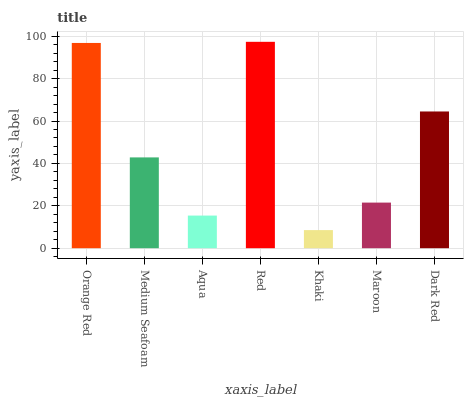Is Khaki the minimum?
Answer yes or no. Yes. Is Red the maximum?
Answer yes or no. Yes. Is Medium Seafoam the minimum?
Answer yes or no. No. Is Medium Seafoam the maximum?
Answer yes or no. No. Is Orange Red greater than Medium Seafoam?
Answer yes or no. Yes. Is Medium Seafoam less than Orange Red?
Answer yes or no. Yes. Is Medium Seafoam greater than Orange Red?
Answer yes or no. No. Is Orange Red less than Medium Seafoam?
Answer yes or no. No. Is Medium Seafoam the high median?
Answer yes or no. Yes. Is Medium Seafoam the low median?
Answer yes or no. Yes. Is Red the high median?
Answer yes or no. No. Is Maroon the low median?
Answer yes or no. No. 